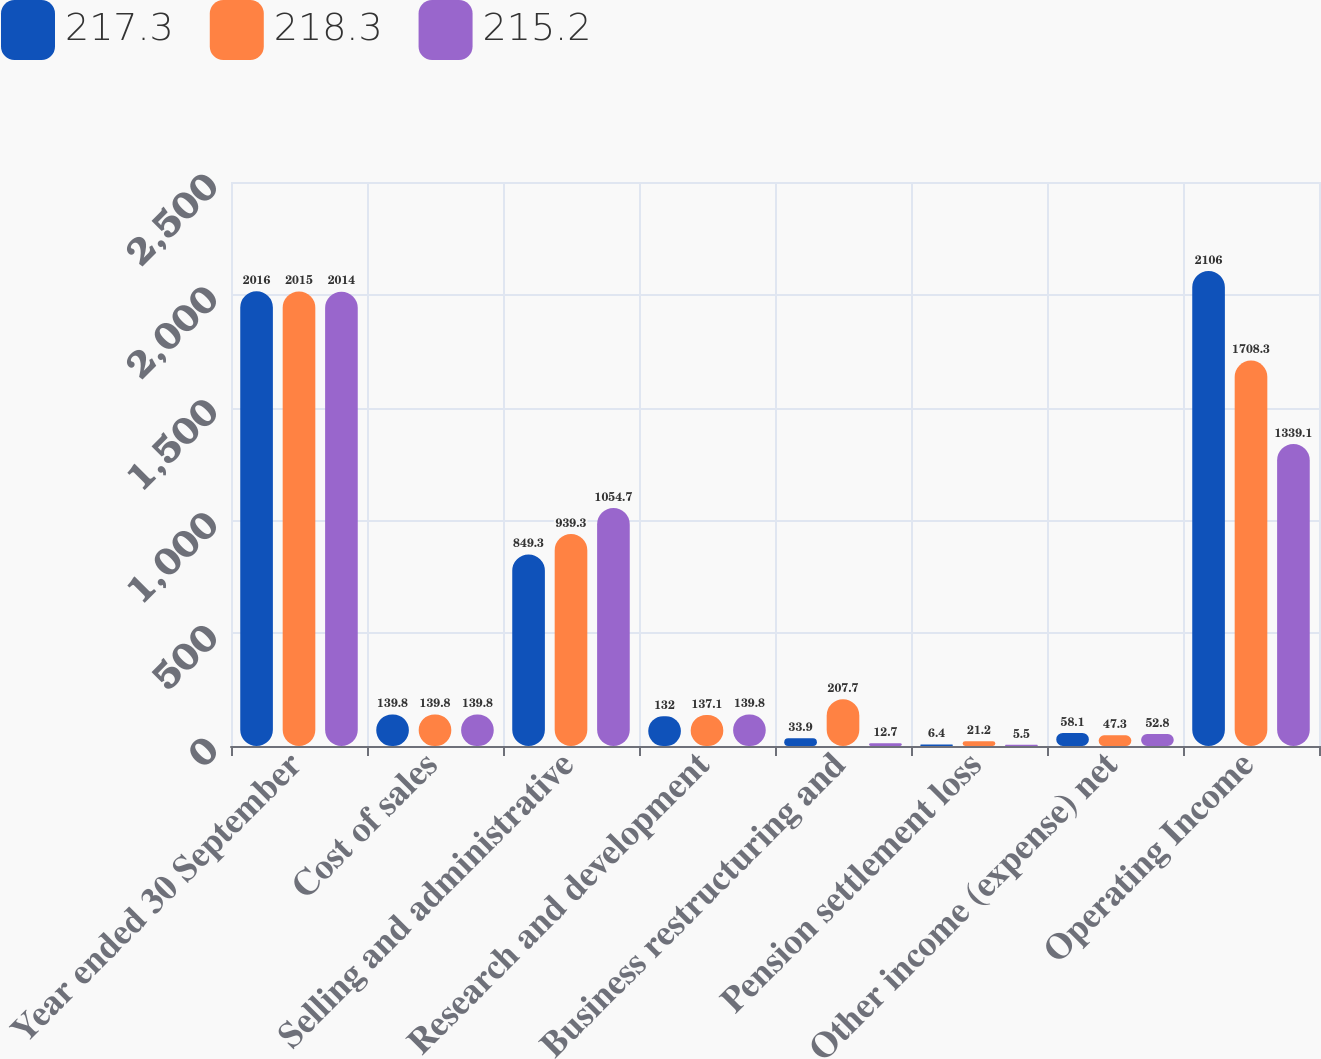Convert chart. <chart><loc_0><loc_0><loc_500><loc_500><stacked_bar_chart><ecel><fcel>Year ended 30 September<fcel>Cost of sales<fcel>Selling and administrative<fcel>Research and development<fcel>Business restructuring and<fcel>Pension settlement loss<fcel>Other income (expense) net<fcel>Operating Income<nl><fcel>217.3<fcel>2016<fcel>139.8<fcel>849.3<fcel>132<fcel>33.9<fcel>6.4<fcel>58.1<fcel>2106<nl><fcel>218.3<fcel>2015<fcel>139.8<fcel>939.3<fcel>137.1<fcel>207.7<fcel>21.2<fcel>47.3<fcel>1708.3<nl><fcel>215.2<fcel>2014<fcel>139.8<fcel>1054.7<fcel>139.8<fcel>12.7<fcel>5.5<fcel>52.8<fcel>1339.1<nl></chart> 